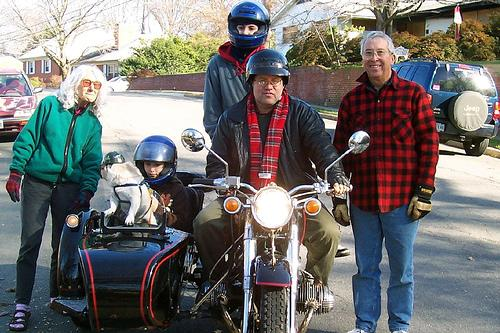What is the little dog wearing in the sidecar?

Choices:
A) helmet
B) scarf
C) hat
D) tshirt helmet 